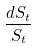<formula> <loc_0><loc_0><loc_500><loc_500>\frac { d S _ { t } } { S _ { t } }</formula> 